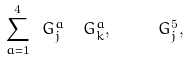<formula> <loc_0><loc_0><loc_500><loc_500>\sum _ { a = 1 } ^ { 4 } \ G _ { j } ^ { a } \ \ G _ { k } ^ { a } , \quad \ G _ { j } ^ { 5 } ,</formula> 